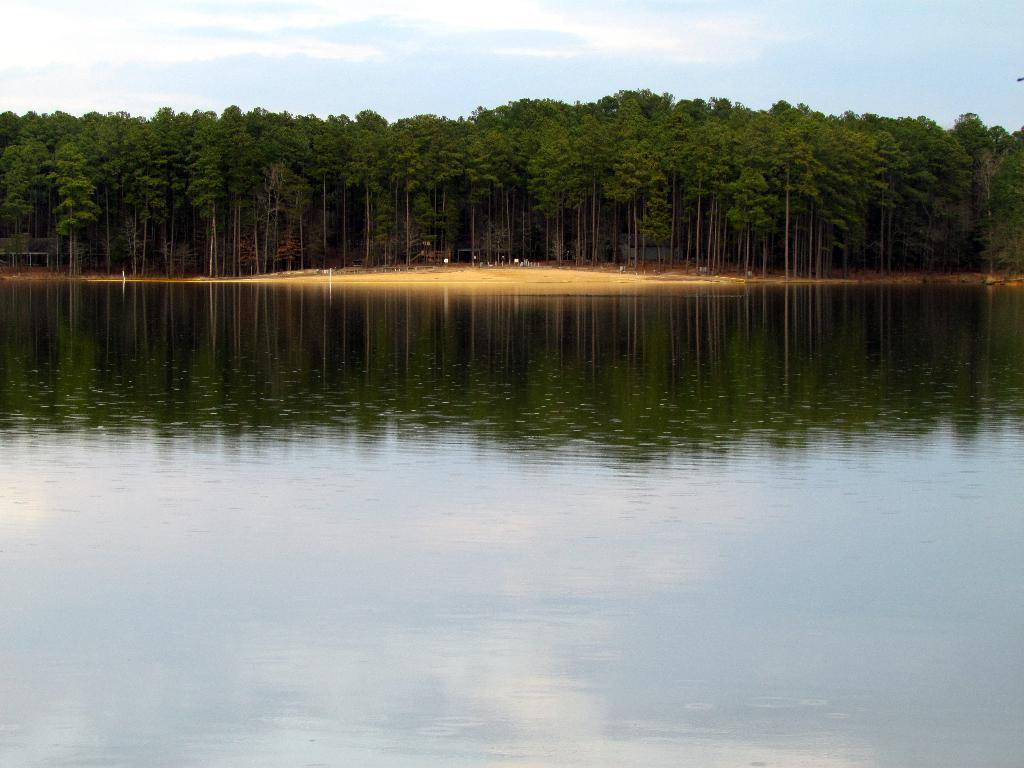What is the primary element visible in the image? There is water in the image. What can be seen in the background of the image? There are trees in the background of the image. What type of seating is available in the image? There are benches in the image. What is visible at the top of the image? The sky is visible at the top of the image. Where is the tent located in the image? There is no tent present in the image. What type of good-bye is being said in the image? There is no good-bye being said in the image; it is a still image with no audible or visible communication. 